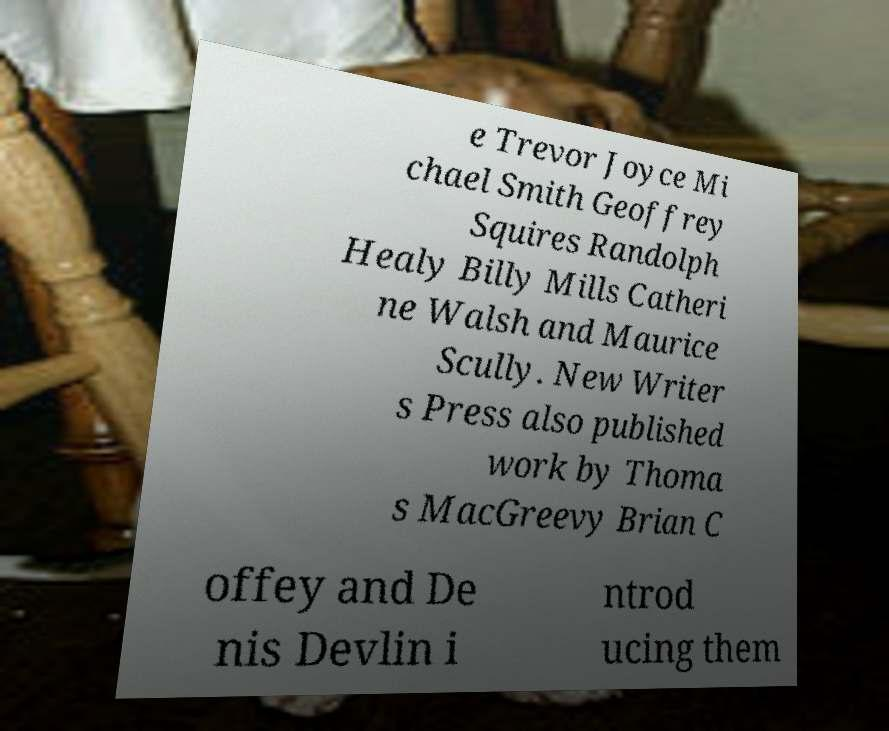There's text embedded in this image that I need extracted. Can you transcribe it verbatim? e Trevor Joyce Mi chael Smith Geoffrey Squires Randolph Healy Billy Mills Catheri ne Walsh and Maurice Scully. New Writer s Press also published work by Thoma s MacGreevy Brian C offey and De nis Devlin i ntrod ucing them 